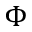Convert formula to latex. <formula><loc_0><loc_0><loc_500><loc_500>\Phi</formula> 